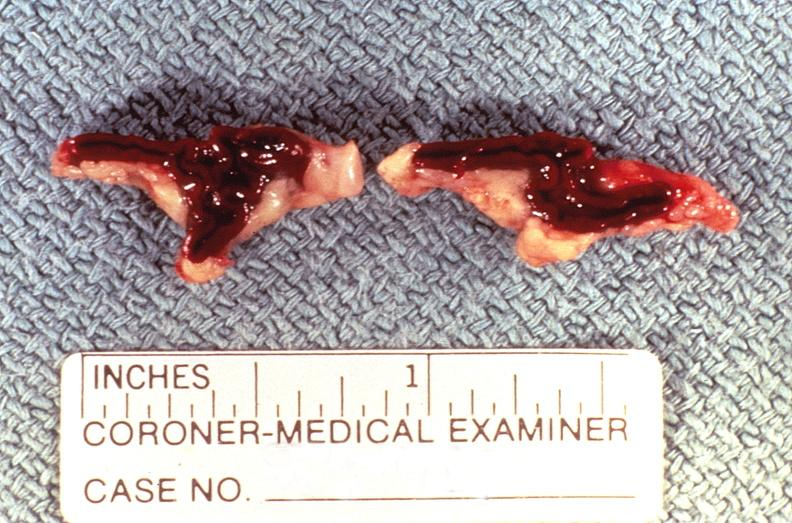what is present?
Answer the question using a single word or phrase. Endocrine 